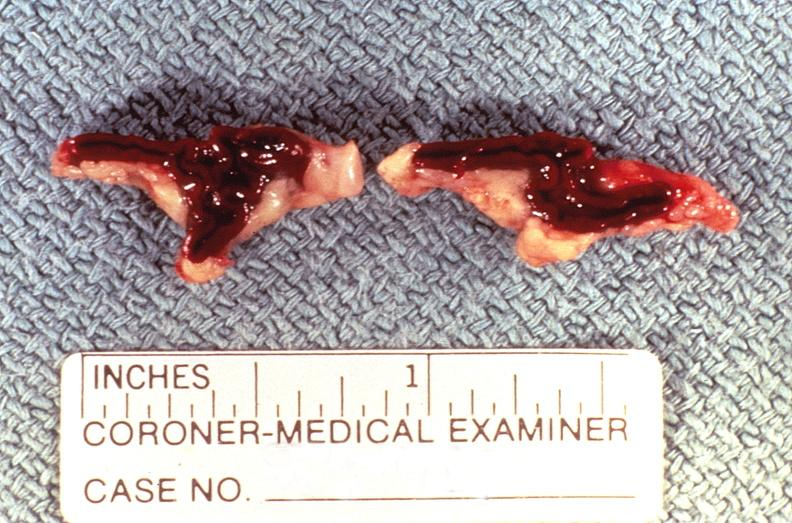what is present?
Answer the question using a single word or phrase. Endocrine 